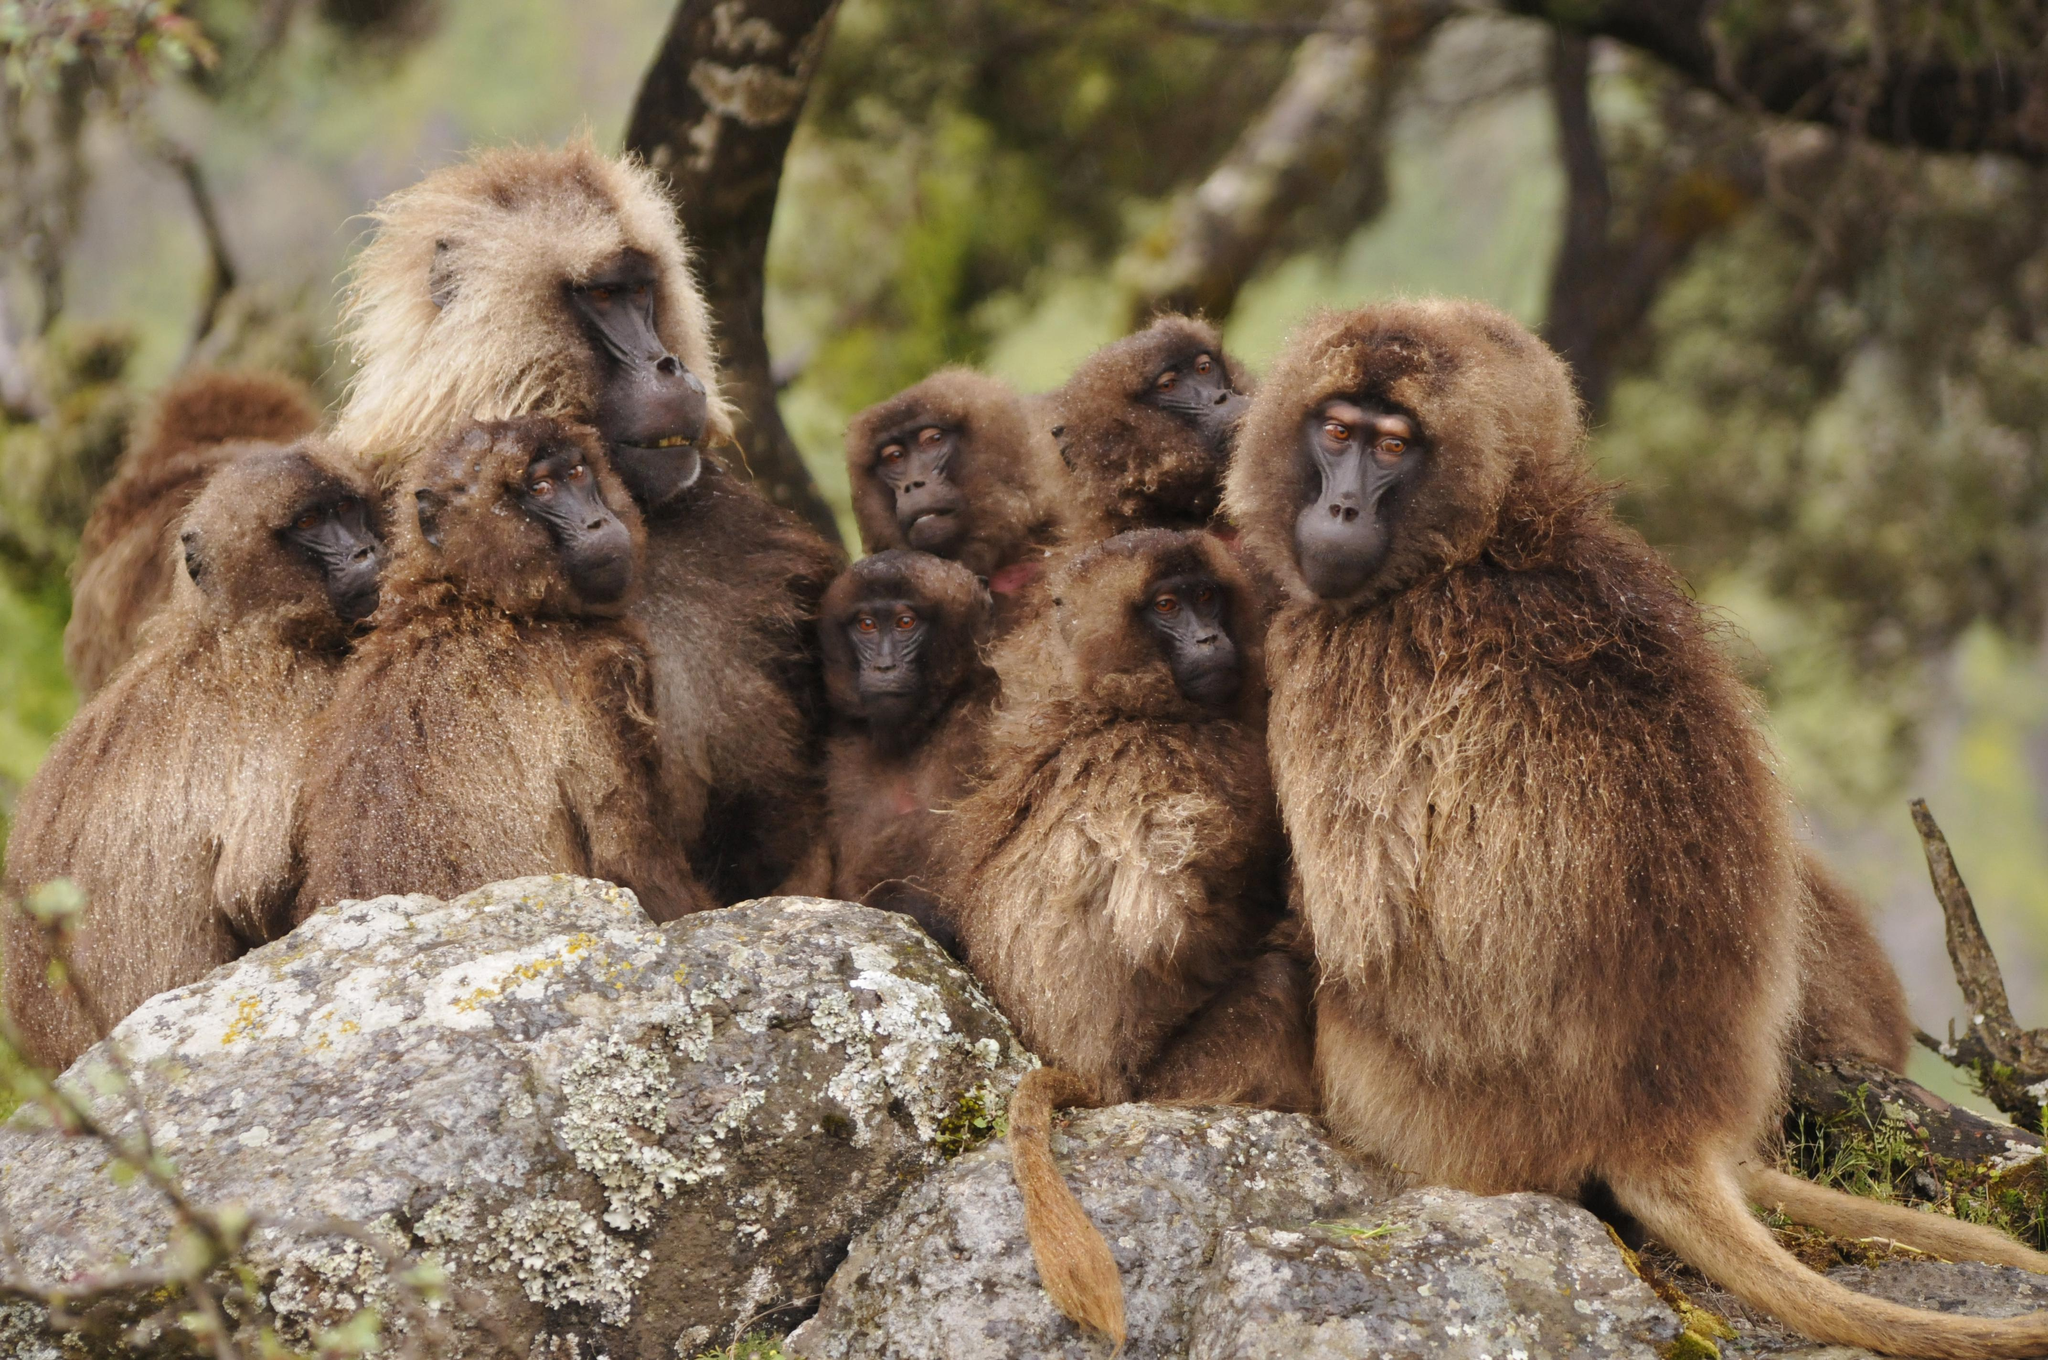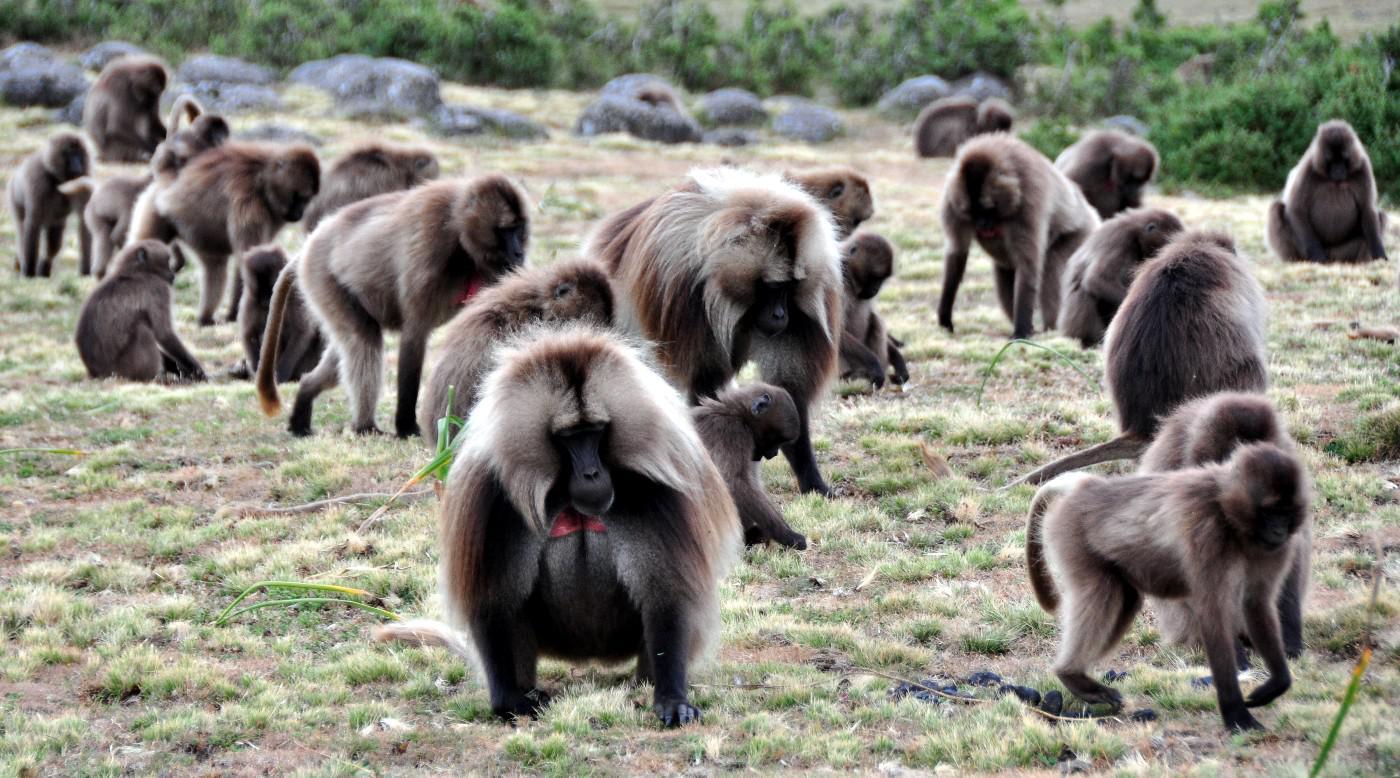The first image is the image on the left, the second image is the image on the right. Assess this claim about the two images: "There are exactly two animals in the image on the right.". Correct or not? Answer yes or no. No. The first image is the image on the left, the second image is the image on the right. For the images displayed, is the sentence "There are no felines in the images." factually correct? Answer yes or no. Yes. The first image is the image on the left, the second image is the image on the right. Given the left and right images, does the statement "There are no more than 4 animals." hold true? Answer yes or no. No. The first image is the image on the left, the second image is the image on the right. Given the left and right images, does the statement "In one of the images there is a primate in close proximity to a large, wild cat." hold true? Answer yes or no. No. 